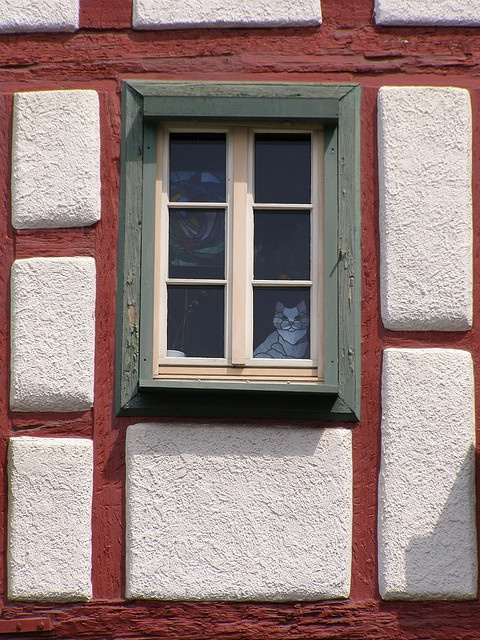Describe the objects in this image and their specific colors. I can see a cat in lightgray, gray, black, and darkblue tones in this image. 